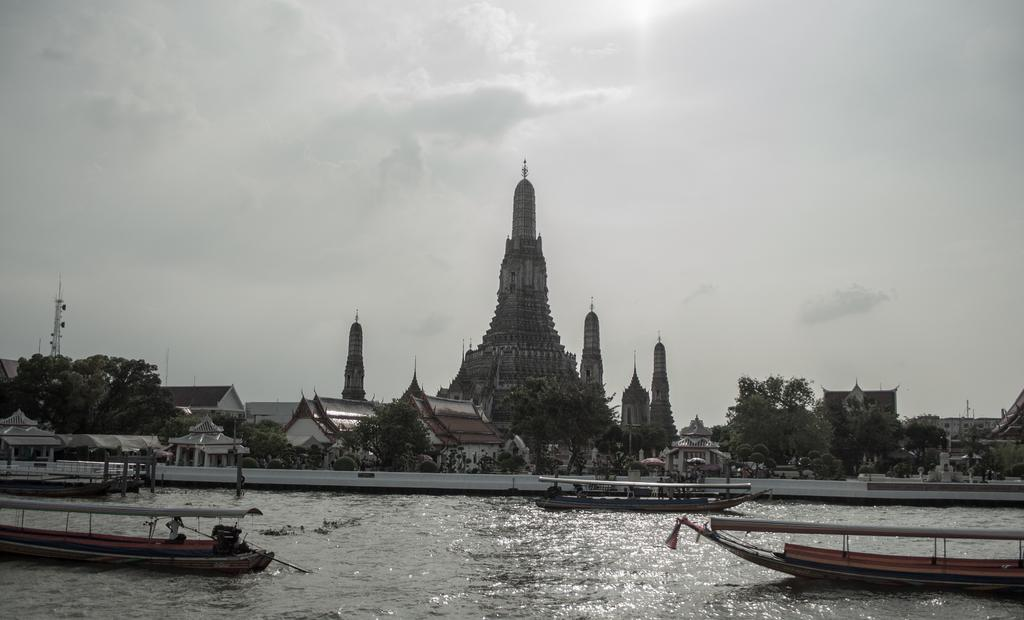What is the primary element in the image? There is water in the image. What is located in the water? There is a boat in the water. Who is in the boat? A man is present in the boat. What can be seen in the background of the image? There are trees and buildings visible in the background. What answer does the man in the boat give to the memory of his uncle? There is no mention of a memory or an uncle in the image, so it is impossible to answer this question. 